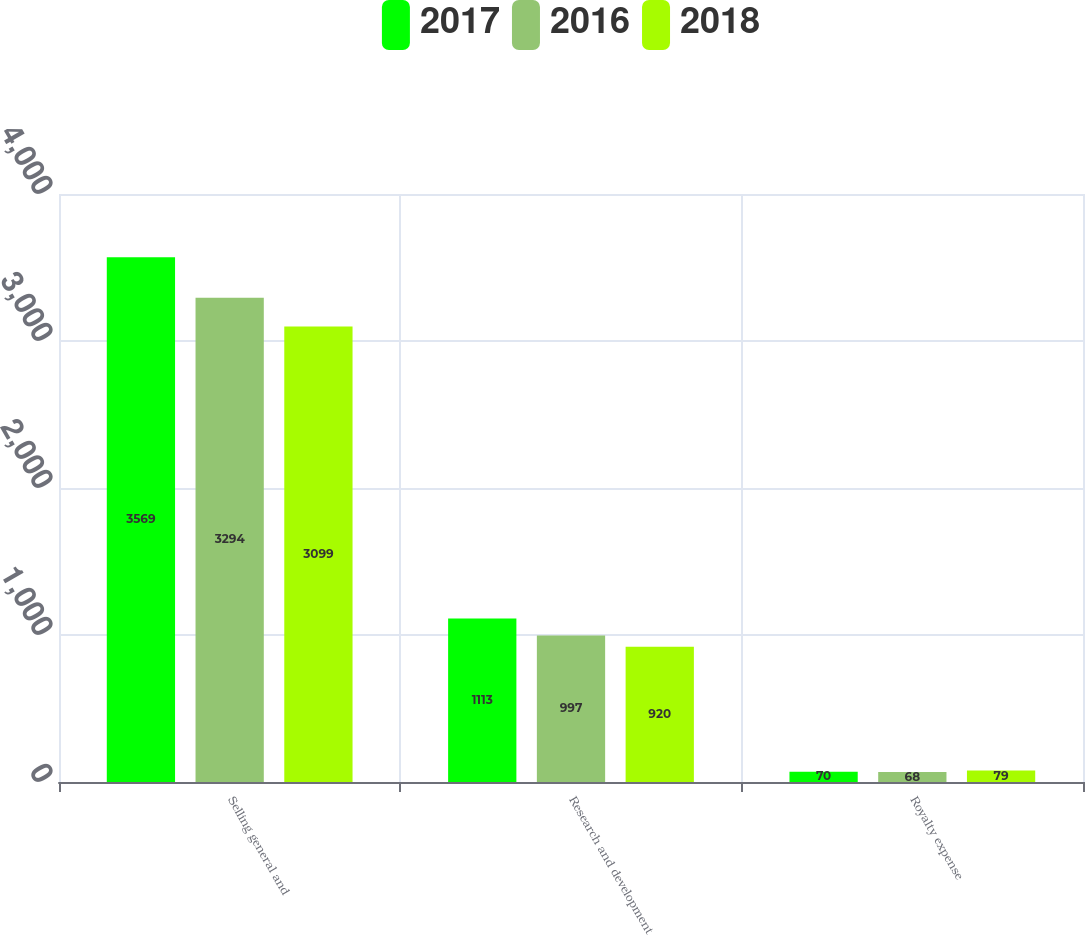Convert chart to OTSL. <chart><loc_0><loc_0><loc_500><loc_500><stacked_bar_chart><ecel><fcel>Selling general and<fcel>Research and development<fcel>Royalty expense<nl><fcel>2017<fcel>3569<fcel>1113<fcel>70<nl><fcel>2016<fcel>3294<fcel>997<fcel>68<nl><fcel>2018<fcel>3099<fcel>920<fcel>79<nl></chart> 